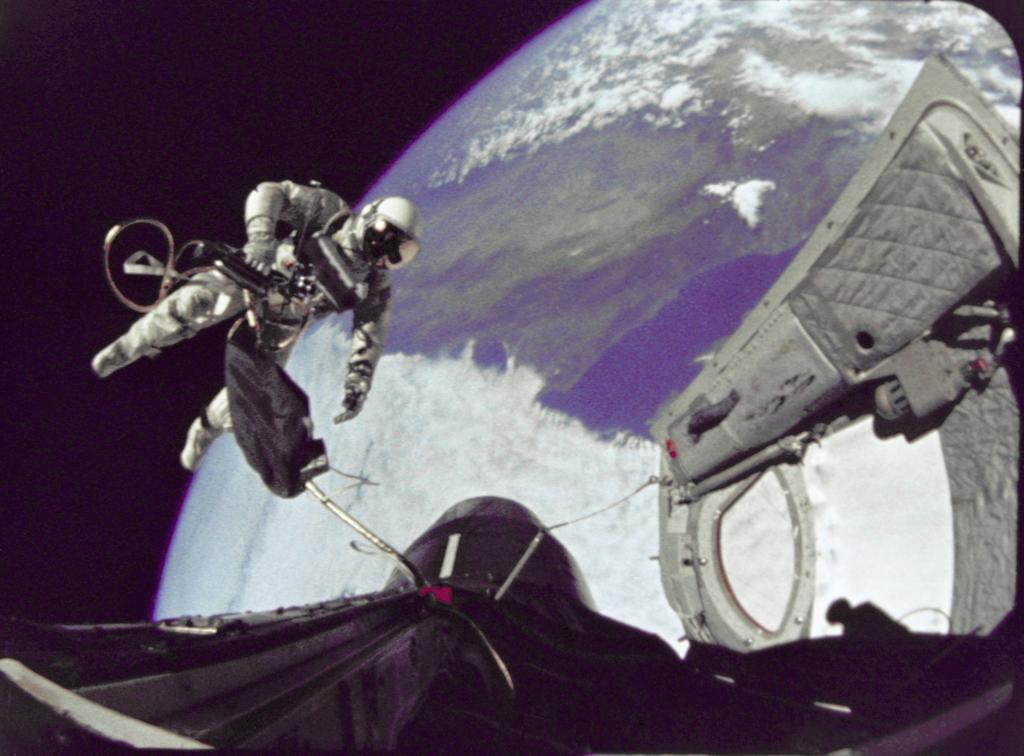What is the main subject of the image? The main subject of the image is a space shuttle. Who is present in the image? There is an astronaut in the image. Where is the astronaut located? The astronaut is in space. What can be seen in the background of the image? The background of the image includes Earth. What type of ornament is hanging from the space shuttle in the image? There is no ornament hanging from the space shuttle in the image. What material is the astronaut's secretary made of in the image? There is no secretary present in the image, as the astronaut is in space. 